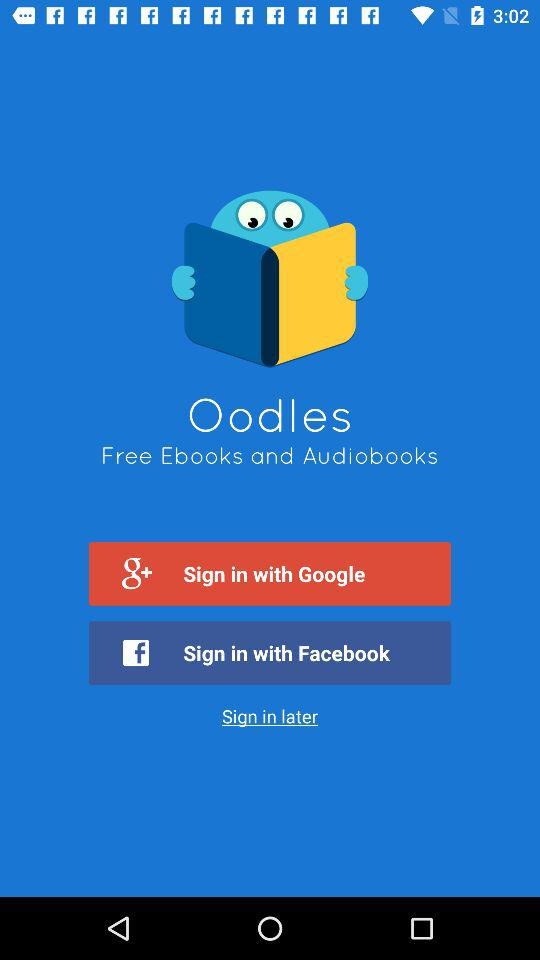What is the name of the application? The name of the application is "Oodles Free Ebooks and Audiobooks". 